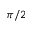Convert formula to latex. <formula><loc_0><loc_0><loc_500><loc_500>\pi / 2</formula> 